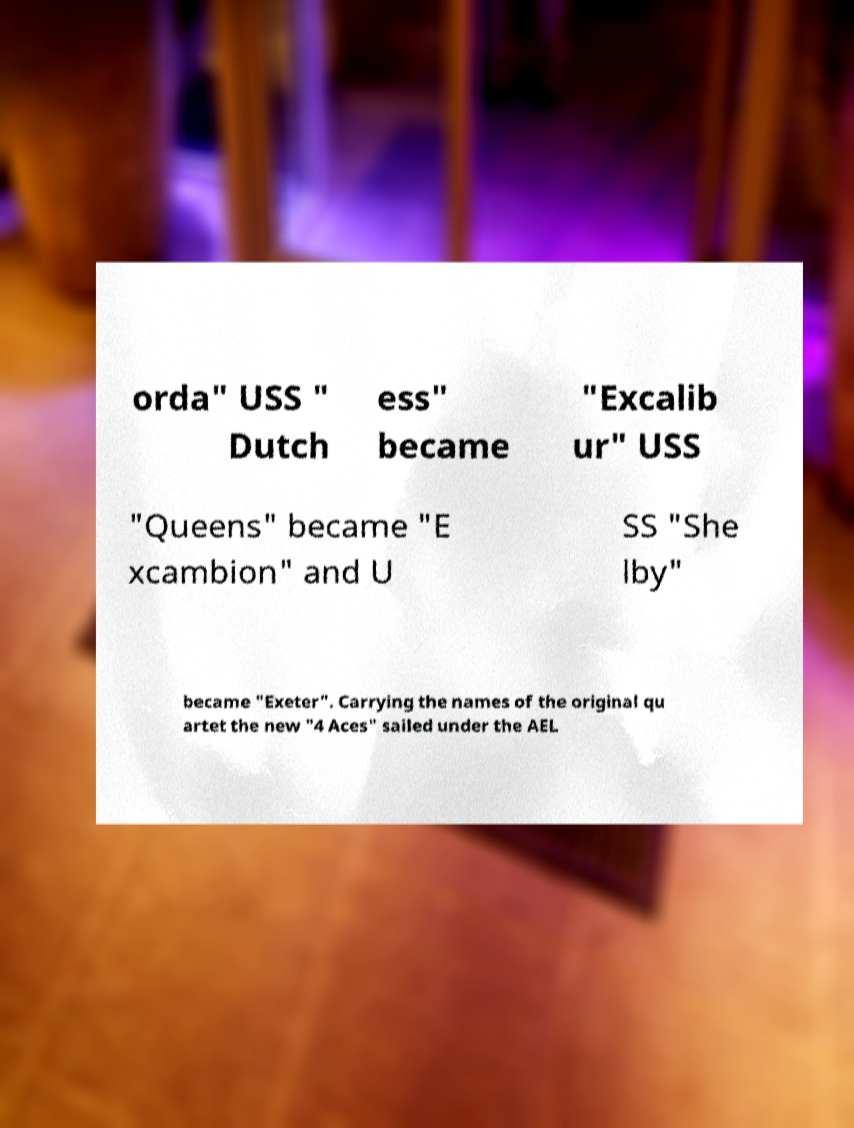What messages or text are displayed in this image? I need them in a readable, typed format. orda" USS " Dutch ess" became "Excalib ur" USS "Queens" became "E xcambion" and U SS "She lby" became "Exeter". Carrying the names of the original qu artet the new "4 Aces" sailed under the AEL 